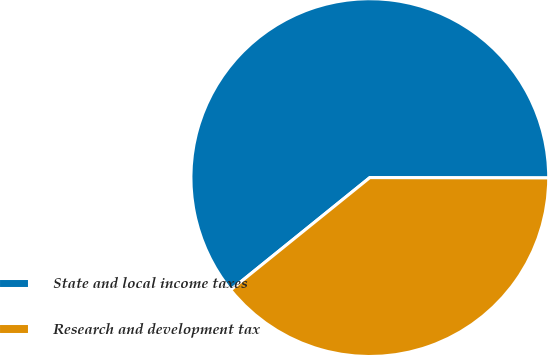Convert chart to OTSL. <chart><loc_0><loc_0><loc_500><loc_500><pie_chart><fcel>State and local income taxes<fcel>Research and development tax<nl><fcel>60.84%<fcel>39.16%<nl></chart> 